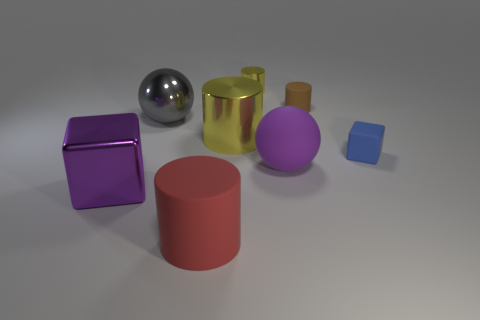The yellow metal object that is the same size as the purple sphere is what shape?
Provide a short and direct response. Cylinder. There is a object that is the same color as the large metallic block; what is its shape?
Your answer should be very brief. Sphere. Does the metallic cylinder behind the brown thing have the same color as the large cylinder that is behind the big purple metal block?
Your response must be concise. Yes. Are there more tiny yellow metallic objects to the right of the blue object than green shiny cylinders?
Your answer should be very brief. No. What material is the large yellow object?
Ensure brevity in your answer.  Metal. The purple thing that is made of the same material as the small blue cube is what shape?
Your answer should be compact. Sphere. How big is the sphere on the right side of the big sphere behind the tiny blue matte cube?
Keep it short and to the point. Large. There is a shiny cylinder that is to the left of the small yellow shiny cylinder; what color is it?
Provide a succinct answer. Yellow. Are there any purple matte objects that have the same shape as the gray metallic thing?
Offer a very short reply. Yes. Is the number of large red matte cylinders that are on the left side of the tiny blue matte cube less than the number of metal things to the left of the big matte cylinder?
Make the answer very short. Yes. 